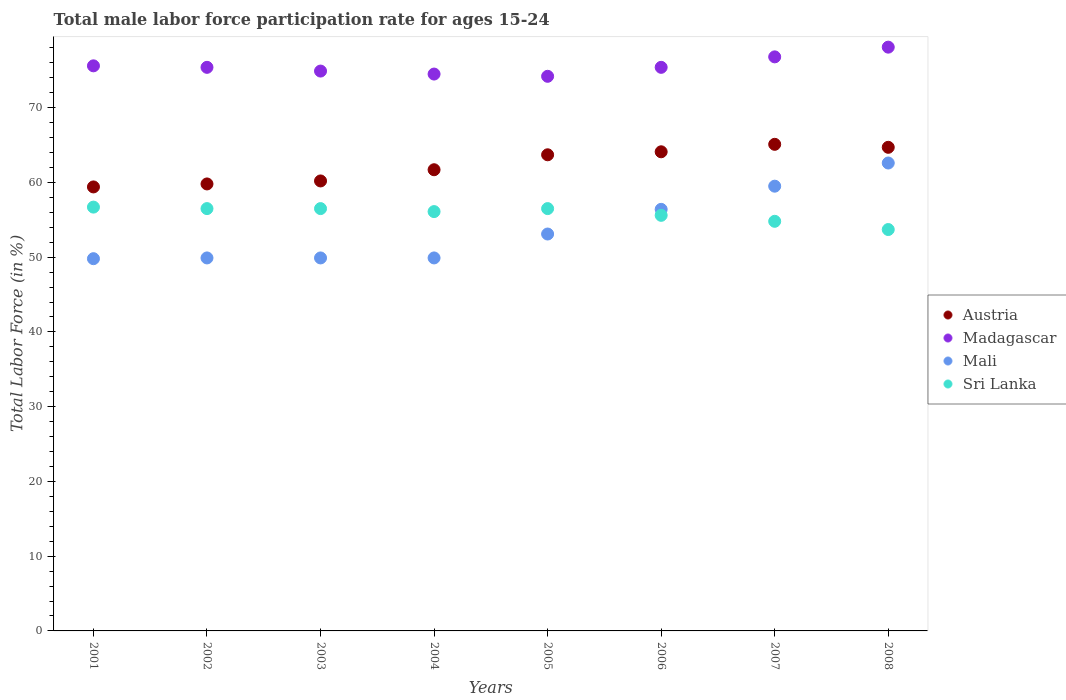How many different coloured dotlines are there?
Your response must be concise. 4. Is the number of dotlines equal to the number of legend labels?
Ensure brevity in your answer.  Yes. What is the male labor force participation rate in Sri Lanka in 2002?
Provide a short and direct response. 56.5. Across all years, what is the maximum male labor force participation rate in Madagascar?
Offer a terse response. 78.1. Across all years, what is the minimum male labor force participation rate in Madagascar?
Offer a terse response. 74.2. In which year was the male labor force participation rate in Austria maximum?
Make the answer very short. 2007. What is the total male labor force participation rate in Sri Lanka in the graph?
Offer a terse response. 446.4. What is the difference between the male labor force participation rate in Sri Lanka in 2001 and that in 2006?
Offer a terse response. 1.1. What is the difference between the male labor force participation rate in Sri Lanka in 2002 and the male labor force participation rate in Mali in 2005?
Keep it short and to the point. 3.4. What is the average male labor force participation rate in Austria per year?
Provide a short and direct response. 62.34. In the year 2003, what is the difference between the male labor force participation rate in Madagascar and male labor force participation rate in Austria?
Your answer should be very brief. 14.7. What is the ratio of the male labor force participation rate in Madagascar in 2003 to that in 2007?
Keep it short and to the point. 0.98. Is the male labor force participation rate in Madagascar in 2002 less than that in 2005?
Keep it short and to the point. No. Is the difference between the male labor force participation rate in Madagascar in 2001 and 2007 greater than the difference between the male labor force participation rate in Austria in 2001 and 2007?
Keep it short and to the point. Yes. What is the difference between the highest and the second highest male labor force participation rate in Sri Lanka?
Your answer should be compact. 0.2. What is the difference between the highest and the lowest male labor force participation rate in Austria?
Your answer should be compact. 5.7. Is the sum of the male labor force participation rate in Austria in 2001 and 2006 greater than the maximum male labor force participation rate in Sri Lanka across all years?
Offer a terse response. Yes. Is it the case that in every year, the sum of the male labor force participation rate in Austria and male labor force participation rate in Sri Lanka  is greater than the male labor force participation rate in Madagascar?
Your answer should be very brief. Yes. Does the male labor force participation rate in Madagascar monotonically increase over the years?
Your answer should be very brief. No. Is the male labor force participation rate in Mali strictly greater than the male labor force participation rate in Austria over the years?
Give a very brief answer. No. How many dotlines are there?
Offer a terse response. 4. What is the difference between two consecutive major ticks on the Y-axis?
Provide a succinct answer. 10. Does the graph contain grids?
Your answer should be very brief. No. Where does the legend appear in the graph?
Keep it short and to the point. Center right. What is the title of the graph?
Offer a very short reply. Total male labor force participation rate for ages 15-24. What is the label or title of the X-axis?
Your response must be concise. Years. What is the label or title of the Y-axis?
Offer a very short reply. Total Labor Force (in %). What is the Total Labor Force (in %) of Austria in 2001?
Your answer should be compact. 59.4. What is the Total Labor Force (in %) of Madagascar in 2001?
Keep it short and to the point. 75.6. What is the Total Labor Force (in %) of Mali in 2001?
Make the answer very short. 49.8. What is the Total Labor Force (in %) of Sri Lanka in 2001?
Your answer should be very brief. 56.7. What is the Total Labor Force (in %) in Austria in 2002?
Give a very brief answer. 59.8. What is the Total Labor Force (in %) of Madagascar in 2002?
Offer a very short reply. 75.4. What is the Total Labor Force (in %) in Mali in 2002?
Make the answer very short. 49.9. What is the Total Labor Force (in %) in Sri Lanka in 2002?
Ensure brevity in your answer.  56.5. What is the Total Labor Force (in %) in Austria in 2003?
Your answer should be compact. 60.2. What is the Total Labor Force (in %) of Madagascar in 2003?
Offer a very short reply. 74.9. What is the Total Labor Force (in %) in Mali in 2003?
Provide a short and direct response. 49.9. What is the Total Labor Force (in %) of Sri Lanka in 2003?
Make the answer very short. 56.5. What is the Total Labor Force (in %) of Austria in 2004?
Offer a very short reply. 61.7. What is the Total Labor Force (in %) of Madagascar in 2004?
Your answer should be compact. 74.5. What is the Total Labor Force (in %) of Mali in 2004?
Offer a terse response. 49.9. What is the Total Labor Force (in %) in Sri Lanka in 2004?
Ensure brevity in your answer.  56.1. What is the Total Labor Force (in %) in Austria in 2005?
Your answer should be very brief. 63.7. What is the Total Labor Force (in %) of Madagascar in 2005?
Offer a terse response. 74.2. What is the Total Labor Force (in %) in Mali in 2005?
Offer a terse response. 53.1. What is the Total Labor Force (in %) of Sri Lanka in 2005?
Provide a short and direct response. 56.5. What is the Total Labor Force (in %) in Austria in 2006?
Your response must be concise. 64.1. What is the Total Labor Force (in %) of Madagascar in 2006?
Offer a very short reply. 75.4. What is the Total Labor Force (in %) of Mali in 2006?
Offer a very short reply. 56.4. What is the Total Labor Force (in %) in Sri Lanka in 2006?
Keep it short and to the point. 55.6. What is the Total Labor Force (in %) of Austria in 2007?
Give a very brief answer. 65.1. What is the Total Labor Force (in %) in Madagascar in 2007?
Give a very brief answer. 76.8. What is the Total Labor Force (in %) in Mali in 2007?
Ensure brevity in your answer.  59.5. What is the Total Labor Force (in %) in Sri Lanka in 2007?
Provide a short and direct response. 54.8. What is the Total Labor Force (in %) of Austria in 2008?
Your answer should be very brief. 64.7. What is the Total Labor Force (in %) in Madagascar in 2008?
Your answer should be compact. 78.1. What is the Total Labor Force (in %) of Mali in 2008?
Keep it short and to the point. 62.6. What is the Total Labor Force (in %) in Sri Lanka in 2008?
Ensure brevity in your answer.  53.7. Across all years, what is the maximum Total Labor Force (in %) of Austria?
Offer a very short reply. 65.1. Across all years, what is the maximum Total Labor Force (in %) of Madagascar?
Your answer should be very brief. 78.1. Across all years, what is the maximum Total Labor Force (in %) in Mali?
Provide a succinct answer. 62.6. Across all years, what is the maximum Total Labor Force (in %) of Sri Lanka?
Give a very brief answer. 56.7. Across all years, what is the minimum Total Labor Force (in %) of Austria?
Provide a succinct answer. 59.4. Across all years, what is the minimum Total Labor Force (in %) of Madagascar?
Make the answer very short. 74.2. Across all years, what is the minimum Total Labor Force (in %) in Mali?
Keep it short and to the point. 49.8. Across all years, what is the minimum Total Labor Force (in %) of Sri Lanka?
Offer a terse response. 53.7. What is the total Total Labor Force (in %) in Austria in the graph?
Ensure brevity in your answer.  498.7. What is the total Total Labor Force (in %) of Madagascar in the graph?
Your answer should be very brief. 604.9. What is the total Total Labor Force (in %) in Mali in the graph?
Offer a terse response. 431.1. What is the total Total Labor Force (in %) in Sri Lanka in the graph?
Keep it short and to the point. 446.4. What is the difference between the Total Labor Force (in %) of Madagascar in 2001 and that in 2002?
Give a very brief answer. 0.2. What is the difference between the Total Labor Force (in %) of Sri Lanka in 2001 and that in 2002?
Give a very brief answer. 0.2. What is the difference between the Total Labor Force (in %) in Austria in 2001 and that in 2003?
Your answer should be very brief. -0.8. What is the difference between the Total Labor Force (in %) of Mali in 2001 and that in 2003?
Offer a very short reply. -0.1. What is the difference between the Total Labor Force (in %) of Austria in 2001 and that in 2004?
Your answer should be very brief. -2.3. What is the difference between the Total Labor Force (in %) of Madagascar in 2001 and that in 2004?
Offer a terse response. 1.1. What is the difference between the Total Labor Force (in %) in Sri Lanka in 2001 and that in 2004?
Your response must be concise. 0.6. What is the difference between the Total Labor Force (in %) of Austria in 2001 and that in 2005?
Your answer should be compact. -4.3. What is the difference between the Total Labor Force (in %) of Madagascar in 2001 and that in 2005?
Provide a short and direct response. 1.4. What is the difference between the Total Labor Force (in %) in Mali in 2001 and that in 2005?
Ensure brevity in your answer.  -3.3. What is the difference between the Total Labor Force (in %) in Sri Lanka in 2001 and that in 2005?
Provide a succinct answer. 0.2. What is the difference between the Total Labor Force (in %) in Austria in 2001 and that in 2006?
Your answer should be compact. -4.7. What is the difference between the Total Labor Force (in %) in Mali in 2001 and that in 2006?
Offer a very short reply. -6.6. What is the difference between the Total Labor Force (in %) of Austria in 2001 and that in 2007?
Your answer should be compact. -5.7. What is the difference between the Total Labor Force (in %) of Madagascar in 2001 and that in 2007?
Provide a short and direct response. -1.2. What is the difference between the Total Labor Force (in %) of Mali in 2001 and that in 2008?
Ensure brevity in your answer.  -12.8. What is the difference between the Total Labor Force (in %) in Sri Lanka in 2001 and that in 2008?
Your answer should be very brief. 3. What is the difference between the Total Labor Force (in %) in Madagascar in 2002 and that in 2003?
Ensure brevity in your answer.  0.5. What is the difference between the Total Labor Force (in %) of Mali in 2002 and that in 2003?
Provide a short and direct response. 0. What is the difference between the Total Labor Force (in %) of Austria in 2002 and that in 2004?
Your answer should be compact. -1.9. What is the difference between the Total Labor Force (in %) of Madagascar in 2002 and that in 2004?
Make the answer very short. 0.9. What is the difference between the Total Labor Force (in %) in Mali in 2002 and that in 2004?
Make the answer very short. 0. What is the difference between the Total Labor Force (in %) in Austria in 2002 and that in 2005?
Provide a succinct answer. -3.9. What is the difference between the Total Labor Force (in %) of Madagascar in 2002 and that in 2005?
Offer a very short reply. 1.2. What is the difference between the Total Labor Force (in %) of Austria in 2002 and that in 2006?
Offer a terse response. -4.3. What is the difference between the Total Labor Force (in %) in Madagascar in 2002 and that in 2006?
Provide a short and direct response. 0. What is the difference between the Total Labor Force (in %) of Sri Lanka in 2002 and that in 2006?
Your answer should be very brief. 0.9. What is the difference between the Total Labor Force (in %) of Austria in 2002 and that in 2007?
Give a very brief answer. -5.3. What is the difference between the Total Labor Force (in %) of Madagascar in 2002 and that in 2007?
Your answer should be very brief. -1.4. What is the difference between the Total Labor Force (in %) of Mali in 2002 and that in 2008?
Your answer should be compact. -12.7. What is the difference between the Total Labor Force (in %) of Sri Lanka in 2002 and that in 2008?
Make the answer very short. 2.8. What is the difference between the Total Labor Force (in %) of Austria in 2003 and that in 2004?
Keep it short and to the point. -1.5. What is the difference between the Total Labor Force (in %) in Mali in 2003 and that in 2004?
Make the answer very short. 0. What is the difference between the Total Labor Force (in %) of Madagascar in 2003 and that in 2005?
Offer a very short reply. 0.7. What is the difference between the Total Labor Force (in %) in Sri Lanka in 2003 and that in 2005?
Your response must be concise. 0. What is the difference between the Total Labor Force (in %) of Austria in 2003 and that in 2006?
Offer a terse response. -3.9. What is the difference between the Total Labor Force (in %) of Madagascar in 2003 and that in 2006?
Make the answer very short. -0.5. What is the difference between the Total Labor Force (in %) of Mali in 2003 and that in 2006?
Offer a terse response. -6.5. What is the difference between the Total Labor Force (in %) in Austria in 2003 and that in 2007?
Ensure brevity in your answer.  -4.9. What is the difference between the Total Labor Force (in %) of Mali in 2003 and that in 2007?
Your answer should be compact. -9.6. What is the difference between the Total Labor Force (in %) of Austria in 2003 and that in 2008?
Your response must be concise. -4.5. What is the difference between the Total Labor Force (in %) in Sri Lanka in 2003 and that in 2008?
Provide a short and direct response. 2.8. What is the difference between the Total Labor Force (in %) of Madagascar in 2004 and that in 2005?
Your answer should be very brief. 0.3. What is the difference between the Total Labor Force (in %) of Mali in 2004 and that in 2005?
Provide a short and direct response. -3.2. What is the difference between the Total Labor Force (in %) in Sri Lanka in 2004 and that in 2005?
Offer a terse response. -0.4. What is the difference between the Total Labor Force (in %) of Austria in 2004 and that in 2006?
Keep it short and to the point. -2.4. What is the difference between the Total Labor Force (in %) of Mali in 2004 and that in 2006?
Offer a very short reply. -6.5. What is the difference between the Total Labor Force (in %) in Sri Lanka in 2004 and that in 2006?
Offer a very short reply. 0.5. What is the difference between the Total Labor Force (in %) of Mali in 2004 and that in 2007?
Your answer should be compact. -9.6. What is the difference between the Total Labor Force (in %) in Sri Lanka in 2004 and that in 2007?
Your response must be concise. 1.3. What is the difference between the Total Labor Force (in %) of Madagascar in 2004 and that in 2008?
Give a very brief answer. -3.6. What is the difference between the Total Labor Force (in %) of Sri Lanka in 2004 and that in 2008?
Your response must be concise. 2.4. What is the difference between the Total Labor Force (in %) of Austria in 2005 and that in 2006?
Give a very brief answer. -0.4. What is the difference between the Total Labor Force (in %) in Madagascar in 2005 and that in 2006?
Your response must be concise. -1.2. What is the difference between the Total Labor Force (in %) of Mali in 2005 and that in 2006?
Keep it short and to the point. -3.3. What is the difference between the Total Labor Force (in %) of Sri Lanka in 2005 and that in 2006?
Offer a very short reply. 0.9. What is the difference between the Total Labor Force (in %) of Sri Lanka in 2005 and that in 2007?
Provide a succinct answer. 1.7. What is the difference between the Total Labor Force (in %) in Austria in 2005 and that in 2008?
Provide a succinct answer. -1. What is the difference between the Total Labor Force (in %) of Madagascar in 2005 and that in 2008?
Offer a terse response. -3.9. What is the difference between the Total Labor Force (in %) of Austria in 2006 and that in 2007?
Your response must be concise. -1. What is the difference between the Total Labor Force (in %) of Madagascar in 2006 and that in 2008?
Ensure brevity in your answer.  -2.7. What is the difference between the Total Labor Force (in %) of Mali in 2006 and that in 2008?
Make the answer very short. -6.2. What is the difference between the Total Labor Force (in %) of Austria in 2001 and the Total Labor Force (in %) of Madagascar in 2002?
Your answer should be compact. -16. What is the difference between the Total Labor Force (in %) of Madagascar in 2001 and the Total Labor Force (in %) of Mali in 2002?
Your response must be concise. 25.7. What is the difference between the Total Labor Force (in %) of Madagascar in 2001 and the Total Labor Force (in %) of Sri Lanka in 2002?
Your response must be concise. 19.1. What is the difference between the Total Labor Force (in %) of Mali in 2001 and the Total Labor Force (in %) of Sri Lanka in 2002?
Ensure brevity in your answer.  -6.7. What is the difference between the Total Labor Force (in %) of Austria in 2001 and the Total Labor Force (in %) of Madagascar in 2003?
Make the answer very short. -15.5. What is the difference between the Total Labor Force (in %) of Austria in 2001 and the Total Labor Force (in %) of Sri Lanka in 2003?
Keep it short and to the point. 2.9. What is the difference between the Total Labor Force (in %) in Madagascar in 2001 and the Total Labor Force (in %) in Mali in 2003?
Offer a very short reply. 25.7. What is the difference between the Total Labor Force (in %) of Mali in 2001 and the Total Labor Force (in %) of Sri Lanka in 2003?
Make the answer very short. -6.7. What is the difference between the Total Labor Force (in %) in Austria in 2001 and the Total Labor Force (in %) in Madagascar in 2004?
Your answer should be compact. -15.1. What is the difference between the Total Labor Force (in %) of Madagascar in 2001 and the Total Labor Force (in %) of Mali in 2004?
Offer a very short reply. 25.7. What is the difference between the Total Labor Force (in %) of Madagascar in 2001 and the Total Labor Force (in %) of Sri Lanka in 2004?
Offer a very short reply. 19.5. What is the difference between the Total Labor Force (in %) of Mali in 2001 and the Total Labor Force (in %) of Sri Lanka in 2004?
Give a very brief answer. -6.3. What is the difference between the Total Labor Force (in %) of Austria in 2001 and the Total Labor Force (in %) of Madagascar in 2005?
Keep it short and to the point. -14.8. What is the difference between the Total Labor Force (in %) of Austria in 2001 and the Total Labor Force (in %) of Mali in 2005?
Keep it short and to the point. 6.3. What is the difference between the Total Labor Force (in %) in Madagascar in 2001 and the Total Labor Force (in %) in Mali in 2005?
Provide a short and direct response. 22.5. What is the difference between the Total Labor Force (in %) in Mali in 2001 and the Total Labor Force (in %) in Sri Lanka in 2005?
Give a very brief answer. -6.7. What is the difference between the Total Labor Force (in %) in Austria in 2001 and the Total Labor Force (in %) in Sri Lanka in 2006?
Make the answer very short. 3.8. What is the difference between the Total Labor Force (in %) of Austria in 2001 and the Total Labor Force (in %) of Madagascar in 2007?
Your answer should be compact. -17.4. What is the difference between the Total Labor Force (in %) of Madagascar in 2001 and the Total Labor Force (in %) of Sri Lanka in 2007?
Provide a succinct answer. 20.8. What is the difference between the Total Labor Force (in %) of Austria in 2001 and the Total Labor Force (in %) of Madagascar in 2008?
Your answer should be very brief. -18.7. What is the difference between the Total Labor Force (in %) of Austria in 2001 and the Total Labor Force (in %) of Sri Lanka in 2008?
Offer a terse response. 5.7. What is the difference between the Total Labor Force (in %) of Madagascar in 2001 and the Total Labor Force (in %) of Mali in 2008?
Offer a very short reply. 13. What is the difference between the Total Labor Force (in %) of Madagascar in 2001 and the Total Labor Force (in %) of Sri Lanka in 2008?
Offer a very short reply. 21.9. What is the difference between the Total Labor Force (in %) in Mali in 2001 and the Total Labor Force (in %) in Sri Lanka in 2008?
Provide a short and direct response. -3.9. What is the difference between the Total Labor Force (in %) of Austria in 2002 and the Total Labor Force (in %) of Madagascar in 2003?
Provide a succinct answer. -15.1. What is the difference between the Total Labor Force (in %) in Madagascar in 2002 and the Total Labor Force (in %) in Sri Lanka in 2003?
Your response must be concise. 18.9. What is the difference between the Total Labor Force (in %) in Austria in 2002 and the Total Labor Force (in %) in Madagascar in 2004?
Your answer should be very brief. -14.7. What is the difference between the Total Labor Force (in %) in Austria in 2002 and the Total Labor Force (in %) in Mali in 2004?
Your answer should be compact. 9.9. What is the difference between the Total Labor Force (in %) in Austria in 2002 and the Total Labor Force (in %) in Sri Lanka in 2004?
Offer a very short reply. 3.7. What is the difference between the Total Labor Force (in %) of Madagascar in 2002 and the Total Labor Force (in %) of Sri Lanka in 2004?
Provide a short and direct response. 19.3. What is the difference between the Total Labor Force (in %) in Austria in 2002 and the Total Labor Force (in %) in Madagascar in 2005?
Keep it short and to the point. -14.4. What is the difference between the Total Labor Force (in %) of Austria in 2002 and the Total Labor Force (in %) of Mali in 2005?
Keep it short and to the point. 6.7. What is the difference between the Total Labor Force (in %) in Austria in 2002 and the Total Labor Force (in %) in Sri Lanka in 2005?
Your response must be concise. 3.3. What is the difference between the Total Labor Force (in %) of Madagascar in 2002 and the Total Labor Force (in %) of Mali in 2005?
Your response must be concise. 22.3. What is the difference between the Total Labor Force (in %) in Madagascar in 2002 and the Total Labor Force (in %) in Sri Lanka in 2005?
Provide a short and direct response. 18.9. What is the difference between the Total Labor Force (in %) in Mali in 2002 and the Total Labor Force (in %) in Sri Lanka in 2005?
Ensure brevity in your answer.  -6.6. What is the difference between the Total Labor Force (in %) of Austria in 2002 and the Total Labor Force (in %) of Madagascar in 2006?
Give a very brief answer. -15.6. What is the difference between the Total Labor Force (in %) of Austria in 2002 and the Total Labor Force (in %) of Sri Lanka in 2006?
Your answer should be very brief. 4.2. What is the difference between the Total Labor Force (in %) in Madagascar in 2002 and the Total Labor Force (in %) in Sri Lanka in 2006?
Your answer should be compact. 19.8. What is the difference between the Total Labor Force (in %) of Austria in 2002 and the Total Labor Force (in %) of Madagascar in 2007?
Your answer should be very brief. -17. What is the difference between the Total Labor Force (in %) in Madagascar in 2002 and the Total Labor Force (in %) in Sri Lanka in 2007?
Offer a terse response. 20.6. What is the difference between the Total Labor Force (in %) of Mali in 2002 and the Total Labor Force (in %) of Sri Lanka in 2007?
Provide a short and direct response. -4.9. What is the difference between the Total Labor Force (in %) in Austria in 2002 and the Total Labor Force (in %) in Madagascar in 2008?
Your answer should be compact. -18.3. What is the difference between the Total Labor Force (in %) in Austria in 2002 and the Total Labor Force (in %) in Sri Lanka in 2008?
Provide a succinct answer. 6.1. What is the difference between the Total Labor Force (in %) of Madagascar in 2002 and the Total Labor Force (in %) of Sri Lanka in 2008?
Provide a short and direct response. 21.7. What is the difference between the Total Labor Force (in %) in Mali in 2002 and the Total Labor Force (in %) in Sri Lanka in 2008?
Your response must be concise. -3.8. What is the difference between the Total Labor Force (in %) in Austria in 2003 and the Total Labor Force (in %) in Madagascar in 2004?
Your response must be concise. -14.3. What is the difference between the Total Labor Force (in %) in Austria in 2003 and the Total Labor Force (in %) in Mali in 2004?
Make the answer very short. 10.3. What is the difference between the Total Labor Force (in %) in Austria in 2003 and the Total Labor Force (in %) in Madagascar in 2005?
Your answer should be compact. -14. What is the difference between the Total Labor Force (in %) of Austria in 2003 and the Total Labor Force (in %) of Sri Lanka in 2005?
Keep it short and to the point. 3.7. What is the difference between the Total Labor Force (in %) in Madagascar in 2003 and the Total Labor Force (in %) in Mali in 2005?
Offer a very short reply. 21.8. What is the difference between the Total Labor Force (in %) of Madagascar in 2003 and the Total Labor Force (in %) of Sri Lanka in 2005?
Provide a succinct answer. 18.4. What is the difference between the Total Labor Force (in %) of Mali in 2003 and the Total Labor Force (in %) of Sri Lanka in 2005?
Provide a short and direct response. -6.6. What is the difference between the Total Labor Force (in %) in Austria in 2003 and the Total Labor Force (in %) in Madagascar in 2006?
Your answer should be compact. -15.2. What is the difference between the Total Labor Force (in %) of Madagascar in 2003 and the Total Labor Force (in %) of Sri Lanka in 2006?
Give a very brief answer. 19.3. What is the difference between the Total Labor Force (in %) in Mali in 2003 and the Total Labor Force (in %) in Sri Lanka in 2006?
Make the answer very short. -5.7. What is the difference between the Total Labor Force (in %) of Austria in 2003 and the Total Labor Force (in %) of Madagascar in 2007?
Make the answer very short. -16.6. What is the difference between the Total Labor Force (in %) of Austria in 2003 and the Total Labor Force (in %) of Mali in 2007?
Offer a terse response. 0.7. What is the difference between the Total Labor Force (in %) in Austria in 2003 and the Total Labor Force (in %) in Sri Lanka in 2007?
Your response must be concise. 5.4. What is the difference between the Total Labor Force (in %) in Madagascar in 2003 and the Total Labor Force (in %) in Sri Lanka in 2007?
Your answer should be very brief. 20.1. What is the difference between the Total Labor Force (in %) in Austria in 2003 and the Total Labor Force (in %) in Madagascar in 2008?
Make the answer very short. -17.9. What is the difference between the Total Labor Force (in %) in Austria in 2003 and the Total Labor Force (in %) in Mali in 2008?
Your answer should be very brief. -2.4. What is the difference between the Total Labor Force (in %) of Austria in 2003 and the Total Labor Force (in %) of Sri Lanka in 2008?
Ensure brevity in your answer.  6.5. What is the difference between the Total Labor Force (in %) in Madagascar in 2003 and the Total Labor Force (in %) in Mali in 2008?
Your answer should be very brief. 12.3. What is the difference between the Total Labor Force (in %) in Madagascar in 2003 and the Total Labor Force (in %) in Sri Lanka in 2008?
Ensure brevity in your answer.  21.2. What is the difference between the Total Labor Force (in %) of Austria in 2004 and the Total Labor Force (in %) of Mali in 2005?
Your answer should be compact. 8.6. What is the difference between the Total Labor Force (in %) of Madagascar in 2004 and the Total Labor Force (in %) of Mali in 2005?
Keep it short and to the point. 21.4. What is the difference between the Total Labor Force (in %) in Mali in 2004 and the Total Labor Force (in %) in Sri Lanka in 2005?
Offer a terse response. -6.6. What is the difference between the Total Labor Force (in %) in Austria in 2004 and the Total Labor Force (in %) in Madagascar in 2006?
Offer a terse response. -13.7. What is the difference between the Total Labor Force (in %) of Madagascar in 2004 and the Total Labor Force (in %) of Sri Lanka in 2006?
Your answer should be compact. 18.9. What is the difference between the Total Labor Force (in %) in Mali in 2004 and the Total Labor Force (in %) in Sri Lanka in 2006?
Give a very brief answer. -5.7. What is the difference between the Total Labor Force (in %) of Austria in 2004 and the Total Labor Force (in %) of Madagascar in 2007?
Keep it short and to the point. -15.1. What is the difference between the Total Labor Force (in %) of Austria in 2004 and the Total Labor Force (in %) of Sri Lanka in 2007?
Your answer should be very brief. 6.9. What is the difference between the Total Labor Force (in %) in Madagascar in 2004 and the Total Labor Force (in %) in Mali in 2007?
Offer a very short reply. 15. What is the difference between the Total Labor Force (in %) in Austria in 2004 and the Total Labor Force (in %) in Madagascar in 2008?
Your answer should be very brief. -16.4. What is the difference between the Total Labor Force (in %) of Austria in 2004 and the Total Labor Force (in %) of Mali in 2008?
Keep it short and to the point. -0.9. What is the difference between the Total Labor Force (in %) of Austria in 2004 and the Total Labor Force (in %) of Sri Lanka in 2008?
Offer a terse response. 8. What is the difference between the Total Labor Force (in %) of Madagascar in 2004 and the Total Labor Force (in %) of Mali in 2008?
Your answer should be very brief. 11.9. What is the difference between the Total Labor Force (in %) of Madagascar in 2004 and the Total Labor Force (in %) of Sri Lanka in 2008?
Offer a terse response. 20.8. What is the difference between the Total Labor Force (in %) of Mali in 2005 and the Total Labor Force (in %) of Sri Lanka in 2006?
Provide a short and direct response. -2.5. What is the difference between the Total Labor Force (in %) of Austria in 2005 and the Total Labor Force (in %) of Madagascar in 2007?
Offer a terse response. -13.1. What is the difference between the Total Labor Force (in %) in Austria in 2005 and the Total Labor Force (in %) in Sri Lanka in 2007?
Ensure brevity in your answer.  8.9. What is the difference between the Total Labor Force (in %) of Madagascar in 2005 and the Total Labor Force (in %) of Mali in 2007?
Make the answer very short. 14.7. What is the difference between the Total Labor Force (in %) in Madagascar in 2005 and the Total Labor Force (in %) in Sri Lanka in 2007?
Your answer should be compact. 19.4. What is the difference between the Total Labor Force (in %) in Austria in 2005 and the Total Labor Force (in %) in Madagascar in 2008?
Your response must be concise. -14.4. What is the difference between the Total Labor Force (in %) in Austria in 2005 and the Total Labor Force (in %) in Sri Lanka in 2008?
Provide a succinct answer. 10. What is the difference between the Total Labor Force (in %) in Madagascar in 2005 and the Total Labor Force (in %) in Sri Lanka in 2008?
Your answer should be very brief. 20.5. What is the difference between the Total Labor Force (in %) of Mali in 2005 and the Total Labor Force (in %) of Sri Lanka in 2008?
Provide a short and direct response. -0.6. What is the difference between the Total Labor Force (in %) of Austria in 2006 and the Total Labor Force (in %) of Mali in 2007?
Your response must be concise. 4.6. What is the difference between the Total Labor Force (in %) in Austria in 2006 and the Total Labor Force (in %) in Sri Lanka in 2007?
Provide a short and direct response. 9.3. What is the difference between the Total Labor Force (in %) in Madagascar in 2006 and the Total Labor Force (in %) in Mali in 2007?
Keep it short and to the point. 15.9. What is the difference between the Total Labor Force (in %) in Madagascar in 2006 and the Total Labor Force (in %) in Sri Lanka in 2007?
Offer a very short reply. 20.6. What is the difference between the Total Labor Force (in %) in Mali in 2006 and the Total Labor Force (in %) in Sri Lanka in 2007?
Keep it short and to the point. 1.6. What is the difference between the Total Labor Force (in %) of Austria in 2006 and the Total Labor Force (in %) of Mali in 2008?
Your answer should be very brief. 1.5. What is the difference between the Total Labor Force (in %) of Madagascar in 2006 and the Total Labor Force (in %) of Mali in 2008?
Your answer should be very brief. 12.8. What is the difference between the Total Labor Force (in %) in Madagascar in 2006 and the Total Labor Force (in %) in Sri Lanka in 2008?
Make the answer very short. 21.7. What is the difference between the Total Labor Force (in %) in Austria in 2007 and the Total Labor Force (in %) in Mali in 2008?
Make the answer very short. 2.5. What is the difference between the Total Labor Force (in %) of Austria in 2007 and the Total Labor Force (in %) of Sri Lanka in 2008?
Provide a succinct answer. 11.4. What is the difference between the Total Labor Force (in %) in Madagascar in 2007 and the Total Labor Force (in %) in Mali in 2008?
Make the answer very short. 14.2. What is the difference between the Total Labor Force (in %) of Madagascar in 2007 and the Total Labor Force (in %) of Sri Lanka in 2008?
Your response must be concise. 23.1. What is the average Total Labor Force (in %) of Austria per year?
Keep it short and to the point. 62.34. What is the average Total Labor Force (in %) of Madagascar per year?
Keep it short and to the point. 75.61. What is the average Total Labor Force (in %) in Mali per year?
Give a very brief answer. 53.89. What is the average Total Labor Force (in %) of Sri Lanka per year?
Keep it short and to the point. 55.8. In the year 2001, what is the difference between the Total Labor Force (in %) of Austria and Total Labor Force (in %) of Madagascar?
Your answer should be very brief. -16.2. In the year 2001, what is the difference between the Total Labor Force (in %) of Austria and Total Labor Force (in %) of Mali?
Make the answer very short. 9.6. In the year 2001, what is the difference between the Total Labor Force (in %) in Madagascar and Total Labor Force (in %) in Mali?
Keep it short and to the point. 25.8. In the year 2001, what is the difference between the Total Labor Force (in %) of Madagascar and Total Labor Force (in %) of Sri Lanka?
Your answer should be compact. 18.9. In the year 2002, what is the difference between the Total Labor Force (in %) of Austria and Total Labor Force (in %) of Madagascar?
Provide a short and direct response. -15.6. In the year 2002, what is the difference between the Total Labor Force (in %) in Austria and Total Labor Force (in %) in Mali?
Ensure brevity in your answer.  9.9. In the year 2002, what is the difference between the Total Labor Force (in %) of Austria and Total Labor Force (in %) of Sri Lanka?
Keep it short and to the point. 3.3. In the year 2002, what is the difference between the Total Labor Force (in %) in Madagascar and Total Labor Force (in %) in Sri Lanka?
Offer a very short reply. 18.9. In the year 2002, what is the difference between the Total Labor Force (in %) of Mali and Total Labor Force (in %) of Sri Lanka?
Keep it short and to the point. -6.6. In the year 2003, what is the difference between the Total Labor Force (in %) in Austria and Total Labor Force (in %) in Madagascar?
Keep it short and to the point. -14.7. In the year 2003, what is the difference between the Total Labor Force (in %) of Austria and Total Labor Force (in %) of Mali?
Your answer should be compact. 10.3. In the year 2003, what is the difference between the Total Labor Force (in %) of Madagascar and Total Labor Force (in %) of Sri Lanka?
Your answer should be compact. 18.4. In the year 2003, what is the difference between the Total Labor Force (in %) in Mali and Total Labor Force (in %) in Sri Lanka?
Ensure brevity in your answer.  -6.6. In the year 2004, what is the difference between the Total Labor Force (in %) in Madagascar and Total Labor Force (in %) in Mali?
Offer a terse response. 24.6. In the year 2004, what is the difference between the Total Labor Force (in %) in Madagascar and Total Labor Force (in %) in Sri Lanka?
Offer a very short reply. 18.4. In the year 2005, what is the difference between the Total Labor Force (in %) of Austria and Total Labor Force (in %) of Mali?
Provide a short and direct response. 10.6. In the year 2005, what is the difference between the Total Labor Force (in %) of Austria and Total Labor Force (in %) of Sri Lanka?
Your answer should be compact. 7.2. In the year 2005, what is the difference between the Total Labor Force (in %) of Madagascar and Total Labor Force (in %) of Mali?
Keep it short and to the point. 21.1. In the year 2005, what is the difference between the Total Labor Force (in %) in Madagascar and Total Labor Force (in %) in Sri Lanka?
Keep it short and to the point. 17.7. In the year 2005, what is the difference between the Total Labor Force (in %) in Mali and Total Labor Force (in %) in Sri Lanka?
Offer a very short reply. -3.4. In the year 2006, what is the difference between the Total Labor Force (in %) in Austria and Total Labor Force (in %) in Madagascar?
Your answer should be very brief. -11.3. In the year 2006, what is the difference between the Total Labor Force (in %) of Austria and Total Labor Force (in %) of Mali?
Your response must be concise. 7.7. In the year 2006, what is the difference between the Total Labor Force (in %) in Madagascar and Total Labor Force (in %) in Sri Lanka?
Provide a short and direct response. 19.8. In the year 2006, what is the difference between the Total Labor Force (in %) of Mali and Total Labor Force (in %) of Sri Lanka?
Make the answer very short. 0.8. In the year 2007, what is the difference between the Total Labor Force (in %) in Austria and Total Labor Force (in %) in Sri Lanka?
Give a very brief answer. 10.3. In the year 2007, what is the difference between the Total Labor Force (in %) in Madagascar and Total Labor Force (in %) in Mali?
Provide a short and direct response. 17.3. In the year 2008, what is the difference between the Total Labor Force (in %) of Austria and Total Labor Force (in %) of Madagascar?
Give a very brief answer. -13.4. In the year 2008, what is the difference between the Total Labor Force (in %) of Madagascar and Total Labor Force (in %) of Sri Lanka?
Give a very brief answer. 24.4. What is the ratio of the Total Labor Force (in %) in Austria in 2001 to that in 2002?
Make the answer very short. 0.99. What is the ratio of the Total Labor Force (in %) of Austria in 2001 to that in 2003?
Your answer should be compact. 0.99. What is the ratio of the Total Labor Force (in %) in Madagascar in 2001 to that in 2003?
Offer a very short reply. 1.01. What is the ratio of the Total Labor Force (in %) in Austria in 2001 to that in 2004?
Provide a succinct answer. 0.96. What is the ratio of the Total Labor Force (in %) in Madagascar in 2001 to that in 2004?
Keep it short and to the point. 1.01. What is the ratio of the Total Labor Force (in %) of Sri Lanka in 2001 to that in 2004?
Your answer should be compact. 1.01. What is the ratio of the Total Labor Force (in %) of Austria in 2001 to that in 2005?
Your answer should be very brief. 0.93. What is the ratio of the Total Labor Force (in %) of Madagascar in 2001 to that in 2005?
Your answer should be very brief. 1.02. What is the ratio of the Total Labor Force (in %) in Mali in 2001 to that in 2005?
Provide a short and direct response. 0.94. What is the ratio of the Total Labor Force (in %) in Austria in 2001 to that in 2006?
Provide a short and direct response. 0.93. What is the ratio of the Total Labor Force (in %) in Mali in 2001 to that in 2006?
Keep it short and to the point. 0.88. What is the ratio of the Total Labor Force (in %) in Sri Lanka in 2001 to that in 2006?
Your response must be concise. 1.02. What is the ratio of the Total Labor Force (in %) of Austria in 2001 to that in 2007?
Keep it short and to the point. 0.91. What is the ratio of the Total Labor Force (in %) of Madagascar in 2001 to that in 2007?
Your answer should be very brief. 0.98. What is the ratio of the Total Labor Force (in %) of Mali in 2001 to that in 2007?
Offer a very short reply. 0.84. What is the ratio of the Total Labor Force (in %) in Sri Lanka in 2001 to that in 2007?
Your answer should be very brief. 1.03. What is the ratio of the Total Labor Force (in %) in Austria in 2001 to that in 2008?
Provide a short and direct response. 0.92. What is the ratio of the Total Labor Force (in %) in Mali in 2001 to that in 2008?
Give a very brief answer. 0.8. What is the ratio of the Total Labor Force (in %) in Sri Lanka in 2001 to that in 2008?
Keep it short and to the point. 1.06. What is the ratio of the Total Labor Force (in %) of Austria in 2002 to that in 2003?
Your response must be concise. 0.99. What is the ratio of the Total Labor Force (in %) of Madagascar in 2002 to that in 2003?
Give a very brief answer. 1.01. What is the ratio of the Total Labor Force (in %) in Mali in 2002 to that in 2003?
Offer a very short reply. 1. What is the ratio of the Total Labor Force (in %) in Sri Lanka in 2002 to that in 2003?
Your answer should be compact. 1. What is the ratio of the Total Labor Force (in %) in Austria in 2002 to that in 2004?
Provide a succinct answer. 0.97. What is the ratio of the Total Labor Force (in %) of Madagascar in 2002 to that in 2004?
Keep it short and to the point. 1.01. What is the ratio of the Total Labor Force (in %) of Sri Lanka in 2002 to that in 2004?
Your answer should be compact. 1.01. What is the ratio of the Total Labor Force (in %) in Austria in 2002 to that in 2005?
Your response must be concise. 0.94. What is the ratio of the Total Labor Force (in %) in Madagascar in 2002 to that in 2005?
Keep it short and to the point. 1.02. What is the ratio of the Total Labor Force (in %) in Mali in 2002 to that in 2005?
Your answer should be compact. 0.94. What is the ratio of the Total Labor Force (in %) in Sri Lanka in 2002 to that in 2005?
Provide a succinct answer. 1. What is the ratio of the Total Labor Force (in %) in Austria in 2002 to that in 2006?
Offer a very short reply. 0.93. What is the ratio of the Total Labor Force (in %) of Madagascar in 2002 to that in 2006?
Keep it short and to the point. 1. What is the ratio of the Total Labor Force (in %) in Mali in 2002 to that in 2006?
Keep it short and to the point. 0.88. What is the ratio of the Total Labor Force (in %) in Sri Lanka in 2002 to that in 2006?
Keep it short and to the point. 1.02. What is the ratio of the Total Labor Force (in %) in Austria in 2002 to that in 2007?
Offer a terse response. 0.92. What is the ratio of the Total Labor Force (in %) of Madagascar in 2002 to that in 2007?
Make the answer very short. 0.98. What is the ratio of the Total Labor Force (in %) of Mali in 2002 to that in 2007?
Offer a very short reply. 0.84. What is the ratio of the Total Labor Force (in %) in Sri Lanka in 2002 to that in 2007?
Provide a succinct answer. 1.03. What is the ratio of the Total Labor Force (in %) of Austria in 2002 to that in 2008?
Make the answer very short. 0.92. What is the ratio of the Total Labor Force (in %) in Madagascar in 2002 to that in 2008?
Your answer should be compact. 0.97. What is the ratio of the Total Labor Force (in %) of Mali in 2002 to that in 2008?
Offer a terse response. 0.8. What is the ratio of the Total Labor Force (in %) in Sri Lanka in 2002 to that in 2008?
Offer a terse response. 1.05. What is the ratio of the Total Labor Force (in %) of Austria in 2003 to that in 2004?
Give a very brief answer. 0.98. What is the ratio of the Total Labor Force (in %) in Madagascar in 2003 to that in 2004?
Make the answer very short. 1.01. What is the ratio of the Total Labor Force (in %) in Sri Lanka in 2003 to that in 2004?
Ensure brevity in your answer.  1.01. What is the ratio of the Total Labor Force (in %) of Austria in 2003 to that in 2005?
Make the answer very short. 0.95. What is the ratio of the Total Labor Force (in %) of Madagascar in 2003 to that in 2005?
Your answer should be very brief. 1.01. What is the ratio of the Total Labor Force (in %) in Mali in 2003 to that in 2005?
Offer a terse response. 0.94. What is the ratio of the Total Labor Force (in %) in Sri Lanka in 2003 to that in 2005?
Provide a succinct answer. 1. What is the ratio of the Total Labor Force (in %) in Austria in 2003 to that in 2006?
Offer a very short reply. 0.94. What is the ratio of the Total Labor Force (in %) of Madagascar in 2003 to that in 2006?
Offer a very short reply. 0.99. What is the ratio of the Total Labor Force (in %) of Mali in 2003 to that in 2006?
Provide a succinct answer. 0.88. What is the ratio of the Total Labor Force (in %) in Sri Lanka in 2003 to that in 2006?
Your answer should be very brief. 1.02. What is the ratio of the Total Labor Force (in %) in Austria in 2003 to that in 2007?
Your answer should be very brief. 0.92. What is the ratio of the Total Labor Force (in %) of Madagascar in 2003 to that in 2007?
Give a very brief answer. 0.98. What is the ratio of the Total Labor Force (in %) in Mali in 2003 to that in 2007?
Make the answer very short. 0.84. What is the ratio of the Total Labor Force (in %) in Sri Lanka in 2003 to that in 2007?
Give a very brief answer. 1.03. What is the ratio of the Total Labor Force (in %) in Austria in 2003 to that in 2008?
Give a very brief answer. 0.93. What is the ratio of the Total Labor Force (in %) in Madagascar in 2003 to that in 2008?
Offer a very short reply. 0.96. What is the ratio of the Total Labor Force (in %) in Mali in 2003 to that in 2008?
Offer a terse response. 0.8. What is the ratio of the Total Labor Force (in %) of Sri Lanka in 2003 to that in 2008?
Offer a terse response. 1.05. What is the ratio of the Total Labor Force (in %) in Austria in 2004 to that in 2005?
Provide a short and direct response. 0.97. What is the ratio of the Total Labor Force (in %) in Madagascar in 2004 to that in 2005?
Make the answer very short. 1. What is the ratio of the Total Labor Force (in %) of Mali in 2004 to that in 2005?
Offer a very short reply. 0.94. What is the ratio of the Total Labor Force (in %) in Austria in 2004 to that in 2006?
Provide a succinct answer. 0.96. What is the ratio of the Total Labor Force (in %) of Mali in 2004 to that in 2006?
Offer a very short reply. 0.88. What is the ratio of the Total Labor Force (in %) in Sri Lanka in 2004 to that in 2006?
Your answer should be very brief. 1.01. What is the ratio of the Total Labor Force (in %) of Austria in 2004 to that in 2007?
Your answer should be very brief. 0.95. What is the ratio of the Total Labor Force (in %) of Madagascar in 2004 to that in 2007?
Provide a succinct answer. 0.97. What is the ratio of the Total Labor Force (in %) in Mali in 2004 to that in 2007?
Offer a terse response. 0.84. What is the ratio of the Total Labor Force (in %) in Sri Lanka in 2004 to that in 2007?
Make the answer very short. 1.02. What is the ratio of the Total Labor Force (in %) of Austria in 2004 to that in 2008?
Provide a succinct answer. 0.95. What is the ratio of the Total Labor Force (in %) of Madagascar in 2004 to that in 2008?
Keep it short and to the point. 0.95. What is the ratio of the Total Labor Force (in %) of Mali in 2004 to that in 2008?
Your response must be concise. 0.8. What is the ratio of the Total Labor Force (in %) of Sri Lanka in 2004 to that in 2008?
Offer a very short reply. 1.04. What is the ratio of the Total Labor Force (in %) of Madagascar in 2005 to that in 2006?
Keep it short and to the point. 0.98. What is the ratio of the Total Labor Force (in %) of Mali in 2005 to that in 2006?
Provide a succinct answer. 0.94. What is the ratio of the Total Labor Force (in %) of Sri Lanka in 2005 to that in 2006?
Your answer should be compact. 1.02. What is the ratio of the Total Labor Force (in %) of Austria in 2005 to that in 2007?
Give a very brief answer. 0.98. What is the ratio of the Total Labor Force (in %) of Madagascar in 2005 to that in 2007?
Your response must be concise. 0.97. What is the ratio of the Total Labor Force (in %) in Mali in 2005 to that in 2007?
Make the answer very short. 0.89. What is the ratio of the Total Labor Force (in %) in Sri Lanka in 2005 to that in 2007?
Give a very brief answer. 1.03. What is the ratio of the Total Labor Force (in %) in Austria in 2005 to that in 2008?
Give a very brief answer. 0.98. What is the ratio of the Total Labor Force (in %) in Madagascar in 2005 to that in 2008?
Offer a very short reply. 0.95. What is the ratio of the Total Labor Force (in %) of Mali in 2005 to that in 2008?
Give a very brief answer. 0.85. What is the ratio of the Total Labor Force (in %) of Sri Lanka in 2005 to that in 2008?
Give a very brief answer. 1.05. What is the ratio of the Total Labor Force (in %) of Austria in 2006 to that in 2007?
Ensure brevity in your answer.  0.98. What is the ratio of the Total Labor Force (in %) in Madagascar in 2006 to that in 2007?
Ensure brevity in your answer.  0.98. What is the ratio of the Total Labor Force (in %) of Mali in 2006 to that in 2007?
Your response must be concise. 0.95. What is the ratio of the Total Labor Force (in %) of Sri Lanka in 2006 to that in 2007?
Give a very brief answer. 1.01. What is the ratio of the Total Labor Force (in %) of Austria in 2006 to that in 2008?
Ensure brevity in your answer.  0.99. What is the ratio of the Total Labor Force (in %) in Madagascar in 2006 to that in 2008?
Provide a succinct answer. 0.97. What is the ratio of the Total Labor Force (in %) in Mali in 2006 to that in 2008?
Keep it short and to the point. 0.9. What is the ratio of the Total Labor Force (in %) in Sri Lanka in 2006 to that in 2008?
Give a very brief answer. 1.04. What is the ratio of the Total Labor Force (in %) of Madagascar in 2007 to that in 2008?
Keep it short and to the point. 0.98. What is the ratio of the Total Labor Force (in %) in Mali in 2007 to that in 2008?
Make the answer very short. 0.95. What is the ratio of the Total Labor Force (in %) in Sri Lanka in 2007 to that in 2008?
Provide a short and direct response. 1.02. What is the difference between the highest and the second highest Total Labor Force (in %) of Austria?
Provide a succinct answer. 0.4. What is the difference between the highest and the second highest Total Labor Force (in %) in Madagascar?
Offer a very short reply. 1.3. What is the difference between the highest and the second highest Total Labor Force (in %) of Mali?
Offer a very short reply. 3.1. What is the difference between the highest and the lowest Total Labor Force (in %) of Austria?
Your response must be concise. 5.7. What is the difference between the highest and the lowest Total Labor Force (in %) in Madagascar?
Keep it short and to the point. 3.9. What is the difference between the highest and the lowest Total Labor Force (in %) of Mali?
Make the answer very short. 12.8. 